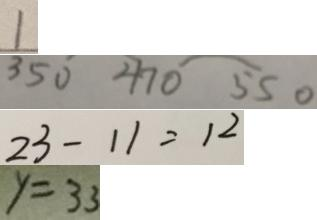<formula> <loc_0><loc_0><loc_500><loc_500>1 
 3 5 0 4 7 0 5 5 0 
 2 3 - 1 1 = 1 2 
 y = 3 3</formula> 